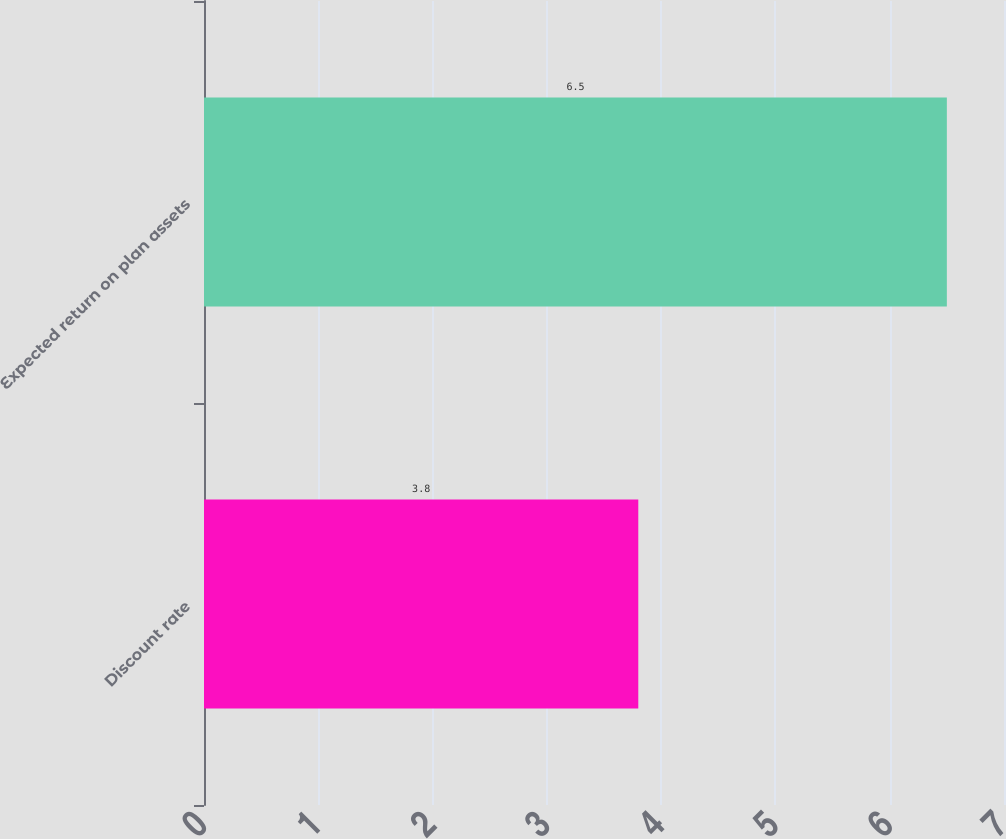<chart> <loc_0><loc_0><loc_500><loc_500><bar_chart><fcel>Discount rate<fcel>Expected return on plan assets<nl><fcel>3.8<fcel>6.5<nl></chart> 